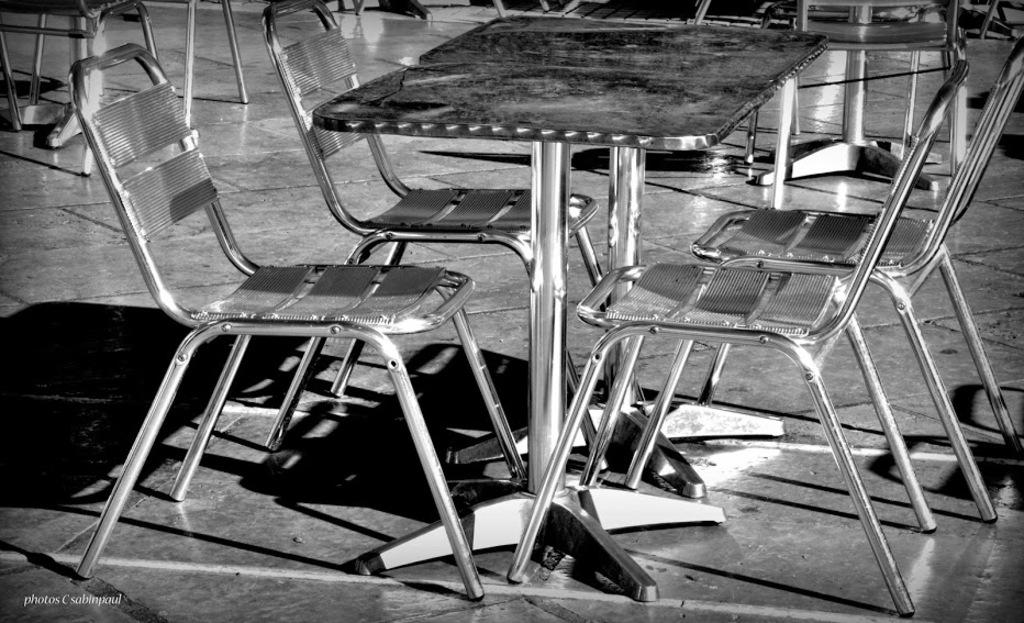What type of chairs are in the image? There are metal chairs in the image. What type of tables are in the image? There are metal tables in the image. What color is the crayon on the tail of the dog in the image? There is no crayon or dog present in the image; it only features metal chairs and tables. 